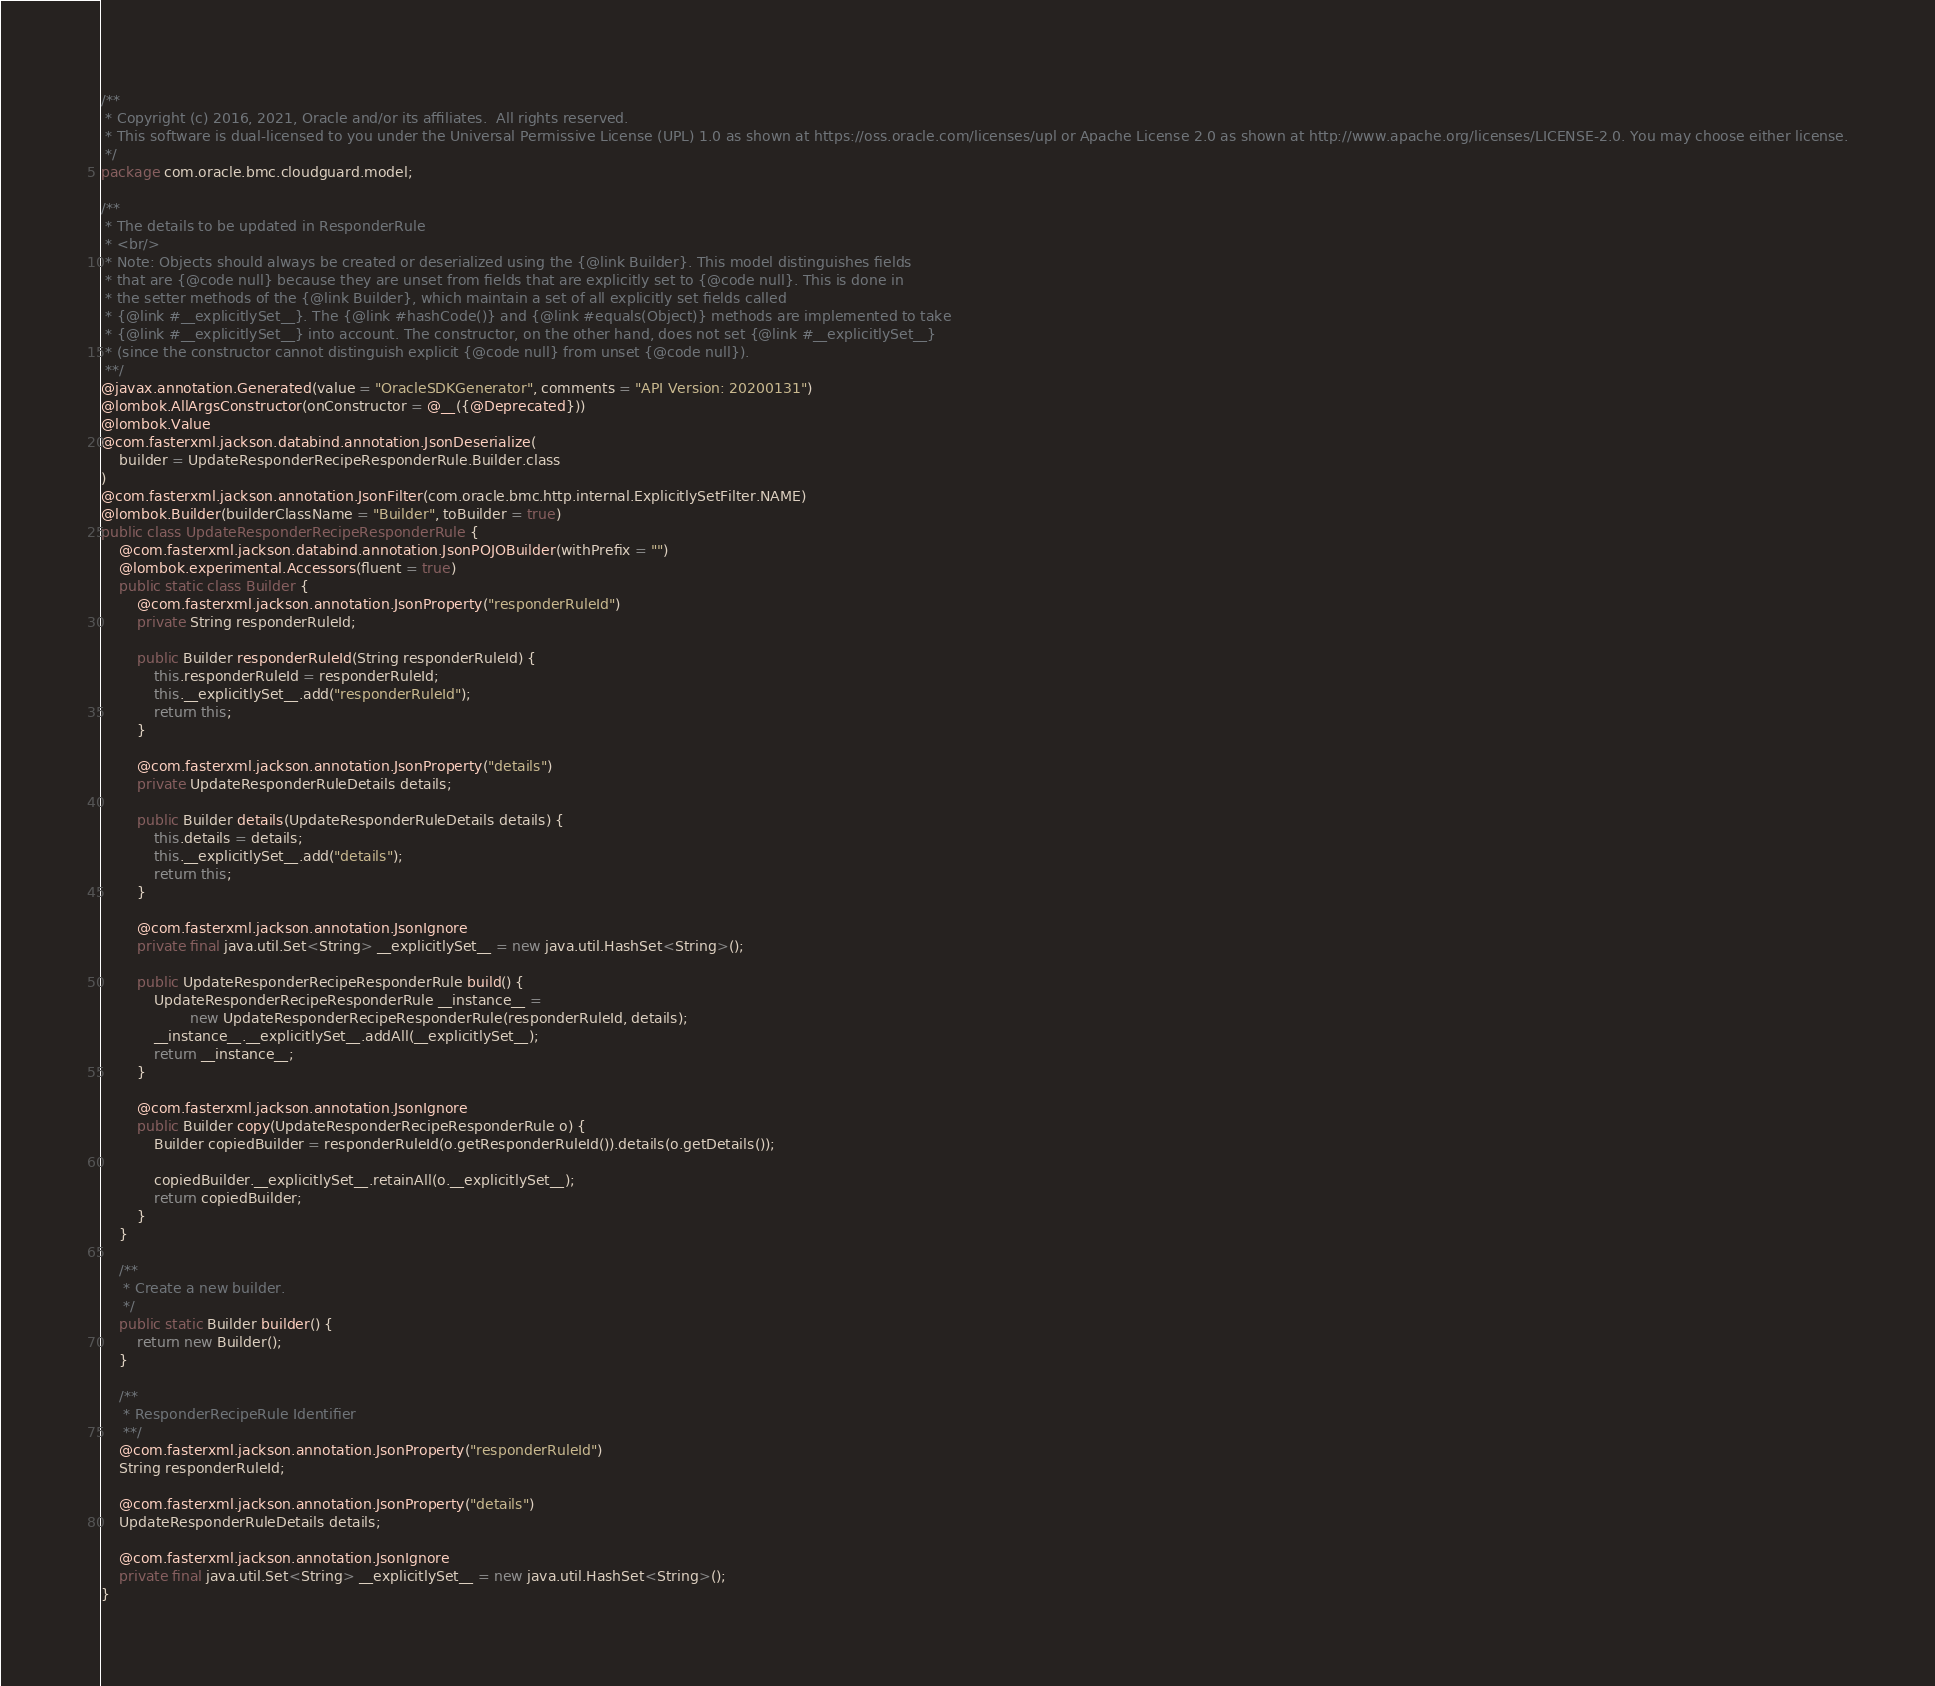<code> <loc_0><loc_0><loc_500><loc_500><_Java_>/**
 * Copyright (c) 2016, 2021, Oracle and/or its affiliates.  All rights reserved.
 * This software is dual-licensed to you under the Universal Permissive License (UPL) 1.0 as shown at https://oss.oracle.com/licenses/upl or Apache License 2.0 as shown at http://www.apache.org/licenses/LICENSE-2.0. You may choose either license.
 */
package com.oracle.bmc.cloudguard.model;

/**
 * The details to be updated in ResponderRule
 * <br/>
 * Note: Objects should always be created or deserialized using the {@link Builder}. This model distinguishes fields
 * that are {@code null} because they are unset from fields that are explicitly set to {@code null}. This is done in
 * the setter methods of the {@link Builder}, which maintain a set of all explicitly set fields called
 * {@link #__explicitlySet__}. The {@link #hashCode()} and {@link #equals(Object)} methods are implemented to take
 * {@link #__explicitlySet__} into account. The constructor, on the other hand, does not set {@link #__explicitlySet__}
 * (since the constructor cannot distinguish explicit {@code null} from unset {@code null}).
 **/
@javax.annotation.Generated(value = "OracleSDKGenerator", comments = "API Version: 20200131")
@lombok.AllArgsConstructor(onConstructor = @__({@Deprecated}))
@lombok.Value
@com.fasterxml.jackson.databind.annotation.JsonDeserialize(
    builder = UpdateResponderRecipeResponderRule.Builder.class
)
@com.fasterxml.jackson.annotation.JsonFilter(com.oracle.bmc.http.internal.ExplicitlySetFilter.NAME)
@lombok.Builder(builderClassName = "Builder", toBuilder = true)
public class UpdateResponderRecipeResponderRule {
    @com.fasterxml.jackson.databind.annotation.JsonPOJOBuilder(withPrefix = "")
    @lombok.experimental.Accessors(fluent = true)
    public static class Builder {
        @com.fasterxml.jackson.annotation.JsonProperty("responderRuleId")
        private String responderRuleId;

        public Builder responderRuleId(String responderRuleId) {
            this.responderRuleId = responderRuleId;
            this.__explicitlySet__.add("responderRuleId");
            return this;
        }

        @com.fasterxml.jackson.annotation.JsonProperty("details")
        private UpdateResponderRuleDetails details;

        public Builder details(UpdateResponderRuleDetails details) {
            this.details = details;
            this.__explicitlySet__.add("details");
            return this;
        }

        @com.fasterxml.jackson.annotation.JsonIgnore
        private final java.util.Set<String> __explicitlySet__ = new java.util.HashSet<String>();

        public UpdateResponderRecipeResponderRule build() {
            UpdateResponderRecipeResponderRule __instance__ =
                    new UpdateResponderRecipeResponderRule(responderRuleId, details);
            __instance__.__explicitlySet__.addAll(__explicitlySet__);
            return __instance__;
        }

        @com.fasterxml.jackson.annotation.JsonIgnore
        public Builder copy(UpdateResponderRecipeResponderRule o) {
            Builder copiedBuilder = responderRuleId(o.getResponderRuleId()).details(o.getDetails());

            copiedBuilder.__explicitlySet__.retainAll(o.__explicitlySet__);
            return copiedBuilder;
        }
    }

    /**
     * Create a new builder.
     */
    public static Builder builder() {
        return new Builder();
    }

    /**
     * ResponderRecipeRule Identifier
     **/
    @com.fasterxml.jackson.annotation.JsonProperty("responderRuleId")
    String responderRuleId;

    @com.fasterxml.jackson.annotation.JsonProperty("details")
    UpdateResponderRuleDetails details;

    @com.fasterxml.jackson.annotation.JsonIgnore
    private final java.util.Set<String> __explicitlySet__ = new java.util.HashSet<String>();
}
</code> 